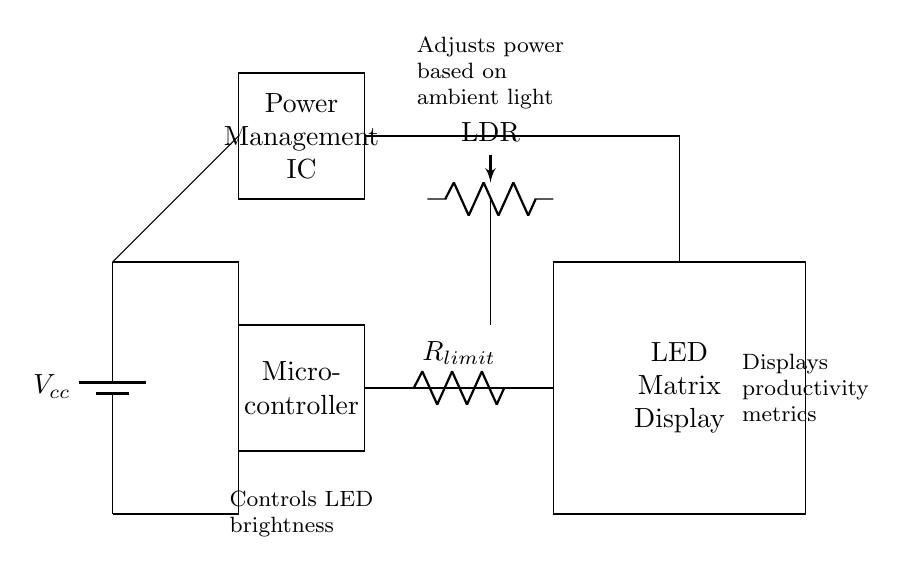What is the voltage supply of the circuit? The voltage supply, noted as Vcc, is represented by a battery symbol in the circuit diagram. Although the exact voltage value is not provided, it is typically a standard voltage, such as 5V.
Answer: Vcc What component adjusts the brightness of the LEDs? The component controlling LED brightness is a Light Dependent Resistor (LDR) shown in the circuit. As the ambient light changes, it adjusts the current to the LED matrix display, thus controlling brightness.
Answer: LDR What is the role of the power management IC? The power management IC adjusts the power provided to the microcontroller and LED matrix based on the input from the LDR, optimizing energy efficiency.
Answer: Adjusts power How many main components are present in this circuit? The main components in the circuit are the battery, microcontroller, LED matrix display, power management IC, and LDR. By counting these in the diagram, we find there are five distinct components.
Answer: Five What is the function of the current limiting resistor? The current limiting resistor, labeled as Rlimit, is used to prevent excessive current from flowing to the LED matrix, which could damage the LEDs.
Answer: Limits current What does the LED matrix display show? The LED matrix display is indicated to show productivity metrics, which can be various performance or engagement indicators in an office setting.
Answer: Productivity metrics How does the circuit manage energy efficiency? The circuit manages energy efficiency through the power management IC, which reduces power consumption based on the input from the LDR, ensuring that the brightness of the LEDs only meets what's necessary.
Answer: Through power management IC 